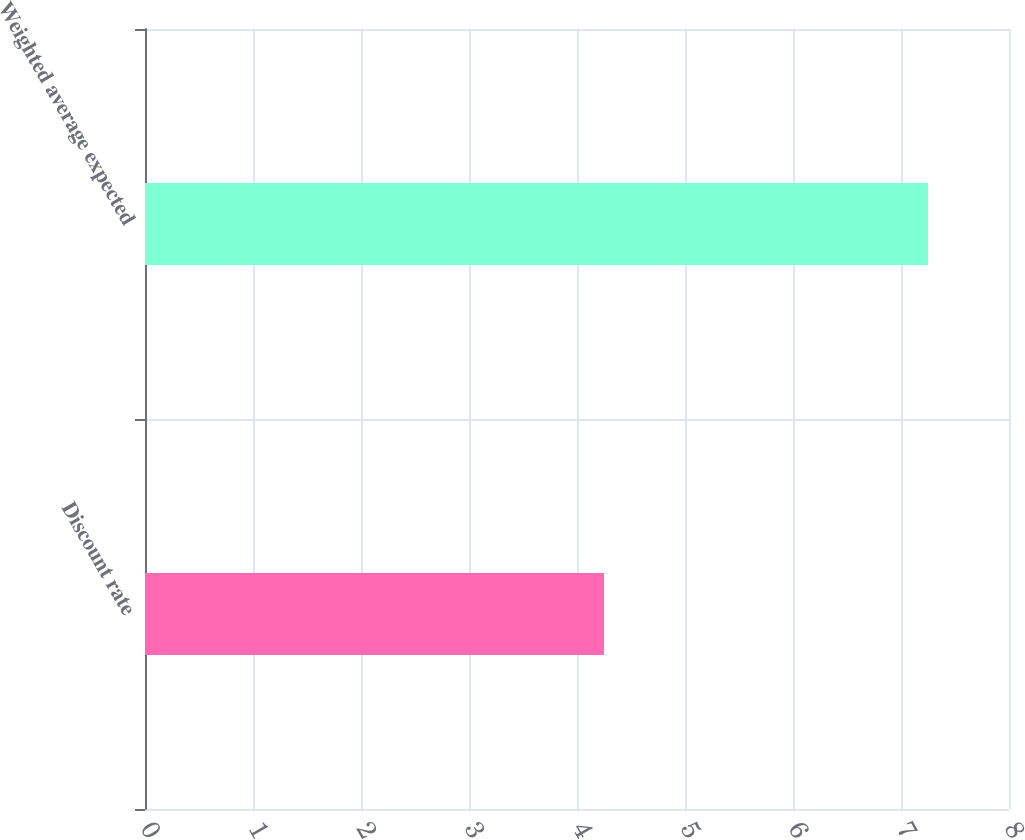Convert chart to OTSL. <chart><loc_0><loc_0><loc_500><loc_500><bar_chart><fcel>Discount rate<fcel>Weighted average expected<nl><fcel>4.25<fcel>7.25<nl></chart> 